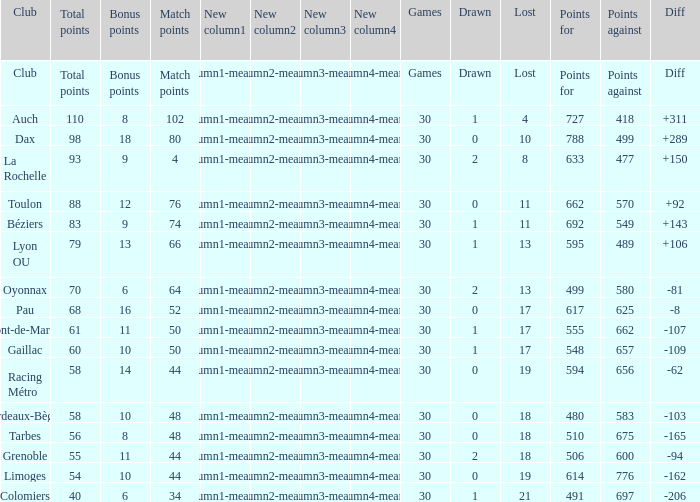What is the value of match points when the points for is 570? 76.0. 